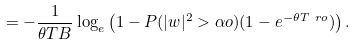Convert formula to latex. <formula><loc_0><loc_0><loc_500><loc_500>& = - \frac { 1 } { \theta T B } \log _ { e } \left ( 1 - P ( | w | ^ { 2 } > \alpha o ) ( 1 - e ^ { - \theta T \ r o } ) \right ) .</formula> 